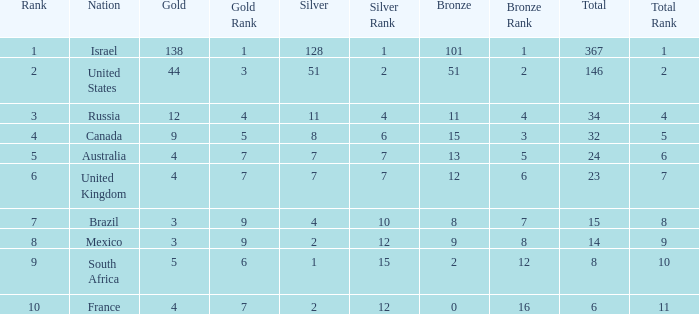What is the gold medal count for the country with a total greater than 32 and more than 128 silvers? None. 